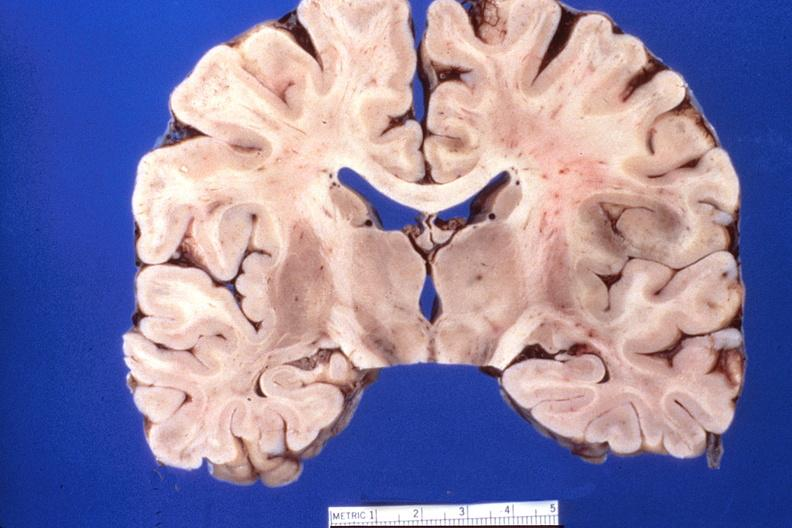what is present?
Answer the question using a single word or phrase. Nervous 